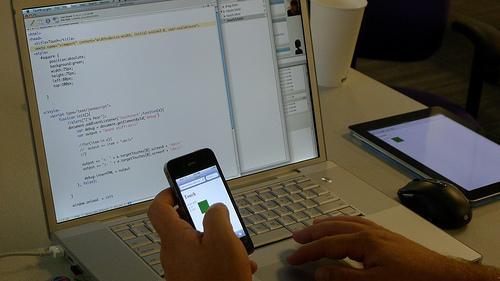How many cups are in the picture?
Give a very brief answer. 1. 